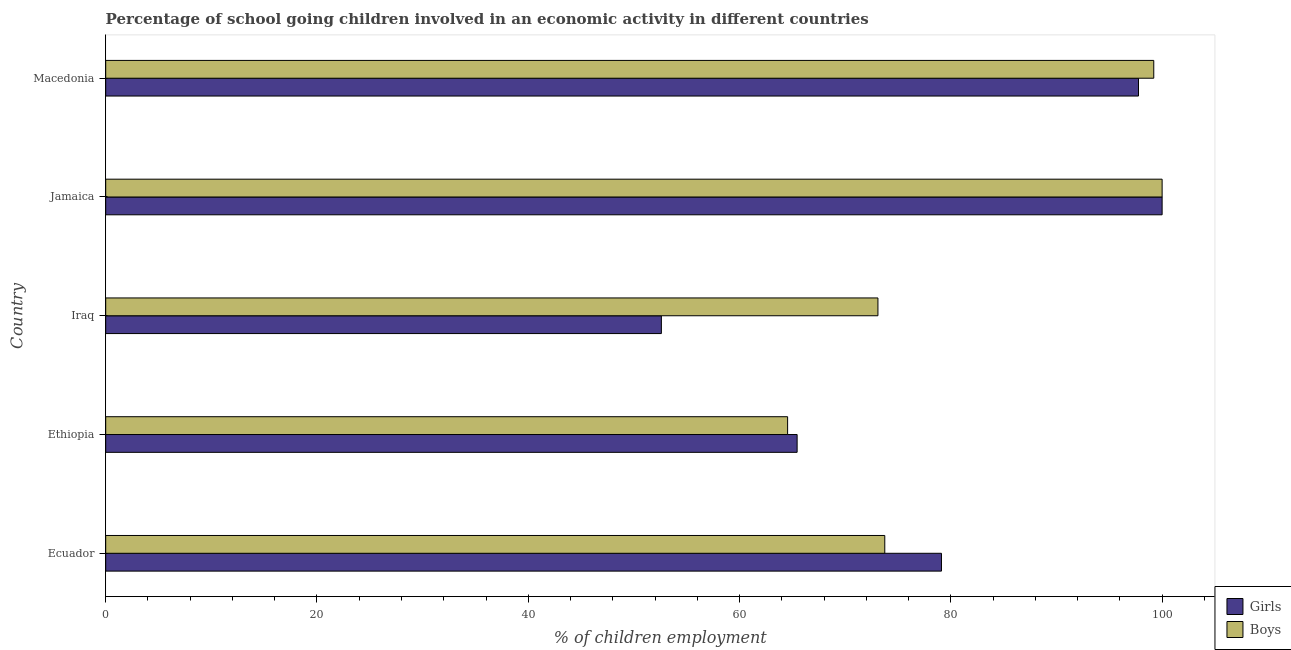Are the number of bars per tick equal to the number of legend labels?
Provide a short and direct response. Yes. How many bars are there on the 2nd tick from the top?
Provide a succinct answer. 2. What is the label of the 3rd group of bars from the top?
Your answer should be very brief. Iraq. In how many cases, is the number of bars for a given country not equal to the number of legend labels?
Your response must be concise. 0. What is the percentage of school going boys in Jamaica?
Ensure brevity in your answer.  100. Across all countries, what is the maximum percentage of school going girls?
Offer a very short reply. 100. Across all countries, what is the minimum percentage of school going girls?
Your response must be concise. 52.6. In which country was the percentage of school going girls maximum?
Provide a short and direct response. Jamaica. In which country was the percentage of school going girls minimum?
Make the answer very short. Iraq. What is the total percentage of school going boys in the graph?
Provide a short and direct response. 410.61. What is the difference between the percentage of school going boys in Jamaica and that in Macedonia?
Ensure brevity in your answer.  0.79. What is the difference between the percentage of school going boys in Ethiopia and the percentage of school going girls in Macedonia?
Offer a terse response. -33.21. What is the average percentage of school going girls per country?
Provide a short and direct response. 78.98. In how many countries, is the percentage of school going boys greater than 88 %?
Your response must be concise. 2. What is the ratio of the percentage of school going boys in Jamaica to that in Macedonia?
Provide a succinct answer. 1.01. What is the difference between the highest and the second highest percentage of school going girls?
Offer a very short reply. 2.24. What is the difference between the highest and the lowest percentage of school going girls?
Give a very brief answer. 47.4. In how many countries, is the percentage of school going girls greater than the average percentage of school going girls taken over all countries?
Provide a succinct answer. 3. What does the 2nd bar from the top in Jamaica represents?
Provide a short and direct response. Girls. What does the 1st bar from the bottom in Ethiopia represents?
Offer a terse response. Girls. Are all the bars in the graph horizontal?
Your answer should be compact. Yes. How many countries are there in the graph?
Make the answer very short. 5. Does the graph contain grids?
Your answer should be compact. No. Where does the legend appear in the graph?
Your answer should be compact. Bottom right. How are the legend labels stacked?
Ensure brevity in your answer.  Vertical. What is the title of the graph?
Offer a very short reply. Percentage of school going children involved in an economic activity in different countries. Does "Food" appear as one of the legend labels in the graph?
Offer a terse response. No. What is the label or title of the X-axis?
Your answer should be very brief. % of children employment. What is the % of children employment in Girls in Ecuador?
Make the answer very short. 79.11. What is the % of children employment in Boys in Ecuador?
Your answer should be compact. 73.75. What is the % of children employment in Girls in Ethiopia?
Give a very brief answer. 65.45. What is the % of children employment in Boys in Ethiopia?
Keep it short and to the point. 64.55. What is the % of children employment of Girls in Iraq?
Your answer should be very brief. 52.6. What is the % of children employment of Boys in Iraq?
Offer a very short reply. 73.1. What is the % of children employment of Girls in Macedonia?
Offer a very short reply. 97.76. What is the % of children employment of Boys in Macedonia?
Give a very brief answer. 99.21. Across all countries, what is the maximum % of children employment in Girls?
Your answer should be compact. 100. Across all countries, what is the minimum % of children employment in Girls?
Give a very brief answer. 52.6. Across all countries, what is the minimum % of children employment of Boys?
Give a very brief answer. 64.55. What is the total % of children employment of Girls in the graph?
Ensure brevity in your answer.  394.93. What is the total % of children employment in Boys in the graph?
Offer a terse response. 410.61. What is the difference between the % of children employment in Girls in Ecuador and that in Ethiopia?
Give a very brief answer. 13.66. What is the difference between the % of children employment in Boys in Ecuador and that in Ethiopia?
Make the answer very short. 9.2. What is the difference between the % of children employment of Girls in Ecuador and that in Iraq?
Keep it short and to the point. 26.51. What is the difference between the % of children employment of Boys in Ecuador and that in Iraq?
Offer a very short reply. 0.65. What is the difference between the % of children employment in Girls in Ecuador and that in Jamaica?
Your answer should be compact. -20.89. What is the difference between the % of children employment of Boys in Ecuador and that in Jamaica?
Offer a terse response. -26.25. What is the difference between the % of children employment of Girls in Ecuador and that in Macedonia?
Your answer should be compact. -18.65. What is the difference between the % of children employment in Boys in Ecuador and that in Macedonia?
Your answer should be compact. -25.46. What is the difference between the % of children employment of Girls in Ethiopia and that in Iraq?
Keep it short and to the point. 12.85. What is the difference between the % of children employment in Boys in Ethiopia and that in Iraq?
Keep it short and to the point. -8.55. What is the difference between the % of children employment in Girls in Ethiopia and that in Jamaica?
Provide a succinct answer. -34.55. What is the difference between the % of children employment in Boys in Ethiopia and that in Jamaica?
Offer a very short reply. -35.45. What is the difference between the % of children employment in Girls in Ethiopia and that in Macedonia?
Give a very brief answer. -32.31. What is the difference between the % of children employment of Boys in Ethiopia and that in Macedonia?
Provide a short and direct response. -34.66. What is the difference between the % of children employment of Girls in Iraq and that in Jamaica?
Give a very brief answer. -47.4. What is the difference between the % of children employment in Boys in Iraq and that in Jamaica?
Offer a terse response. -26.9. What is the difference between the % of children employment of Girls in Iraq and that in Macedonia?
Provide a short and direct response. -45.16. What is the difference between the % of children employment of Boys in Iraq and that in Macedonia?
Make the answer very short. -26.11. What is the difference between the % of children employment in Girls in Jamaica and that in Macedonia?
Provide a succinct answer. 2.24. What is the difference between the % of children employment in Boys in Jamaica and that in Macedonia?
Keep it short and to the point. 0.79. What is the difference between the % of children employment of Girls in Ecuador and the % of children employment of Boys in Ethiopia?
Provide a short and direct response. 14.56. What is the difference between the % of children employment of Girls in Ecuador and the % of children employment of Boys in Iraq?
Provide a succinct answer. 6.01. What is the difference between the % of children employment of Girls in Ecuador and the % of children employment of Boys in Jamaica?
Make the answer very short. -20.89. What is the difference between the % of children employment of Girls in Ecuador and the % of children employment of Boys in Macedonia?
Give a very brief answer. -20.1. What is the difference between the % of children employment in Girls in Ethiopia and the % of children employment in Boys in Iraq?
Ensure brevity in your answer.  -7.65. What is the difference between the % of children employment in Girls in Ethiopia and the % of children employment in Boys in Jamaica?
Your answer should be very brief. -34.55. What is the difference between the % of children employment in Girls in Ethiopia and the % of children employment in Boys in Macedonia?
Keep it short and to the point. -33.76. What is the difference between the % of children employment in Girls in Iraq and the % of children employment in Boys in Jamaica?
Give a very brief answer. -47.4. What is the difference between the % of children employment in Girls in Iraq and the % of children employment in Boys in Macedonia?
Offer a very short reply. -46.61. What is the difference between the % of children employment of Girls in Jamaica and the % of children employment of Boys in Macedonia?
Ensure brevity in your answer.  0.79. What is the average % of children employment of Girls per country?
Give a very brief answer. 78.99. What is the average % of children employment in Boys per country?
Make the answer very short. 82.12. What is the difference between the % of children employment in Girls and % of children employment in Boys in Ecuador?
Give a very brief answer. 5.37. What is the difference between the % of children employment of Girls and % of children employment of Boys in Ethiopia?
Make the answer very short. 0.9. What is the difference between the % of children employment in Girls and % of children employment in Boys in Iraq?
Offer a very short reply. -20.5. What is the difference between the % of children employment of Girls and % of children employment of Boys in Macedonia?
Your response must be concise. -1.45. What is the ratio of the % of children employment in Girls in Ecuador to that in Ethiopia?
Ensure brevity in your answer.  1.21. What is the ratio of the % of children employment of Boys in Ecuador to that in Ethiopia?
Ensure brevity in your answer.  1.14. What is the ratio of the % of children employment of Girls in Ecuador to that in Iraq?
Keep it short and to the point. 1.5. What is the ratio of the % of children employment in Boys in Ecuador to that in Iraq?
Provide a succinct answer. 1.01. What is the ratio of the % of children employment in Girls in Ecuador to that in Jamaica?
Offer a very short reply. 0.79. What is the ratio of the % of children employment in Boys in Ecuador to that in Jamaica?
Keep it short and to the point. 0.74. What is the ratio of the % of children employment in Girls in Ecuador to that in Macedonia?
Offer a very short reply. 0.81. What is the ratio of the % of children employment in Boys in Ecuador to that in Macedonia?
Your answer should be very brief. 0.74. What is the ratio of the % of children employment of Girls in Ethiopia to that in Iraq?
Offer a terse response. 1.24. What is the ratio of the % of children employment of Boys in Ethiopia to that in Iraq?
Offer a very short reply. 0.88. What is the ratio of the % of children employment of Girls in Ethiopia to that in Jamaica?
Offer a very short reply. 0.65. What is the ratio of the % of children employment in Boys in Ethiopia to that in Jamaica?
Your response must be concise. 0.65. What is the ratio of the % of children employment in Girls in Ethiopia to that in Macedonia?
Your response must be concise. 0.67. What is the ratio of the % of children employment in Boys in Ethiopia to that in Macedonia?
Provide a short and direct response. 0.65. What is the ratio of the % of children employment of Girls in Iraq to that in Jamaica?
Your answer should be compact. 0.53. What is the ratio of the % of children employment in Boys in Iraq to that in Jamaica?
Offer a very short reply. 0.73. What is the ratio of the % of children employment in Girls in Iraq to that in Macedonia?
Keep it short and to the point. 0.54. What is the ratio of the % of children employment in Boys in Iraq to that in Macedonia?
Offer a very short reply. 0.74. What is the ratio of the % of children employment of Girls in Jamaica to that in Macedonia?
Provide a succinct answer. 1.02. What is the difference between the highest and the second highest % of children employment of Girls?
Provide a short and direct response. 2.24. What is the difference between the highest and the second highest % of children employment in Boys?
Provide a succinct answer. 0.79. What is the difference between the highest and the lowest % of children employment of Girls?
Offer a terse response. 47.4. What is the difference between the highest and the lowest % of children employment in Boys?
Give a very brief answer. 35.45. 